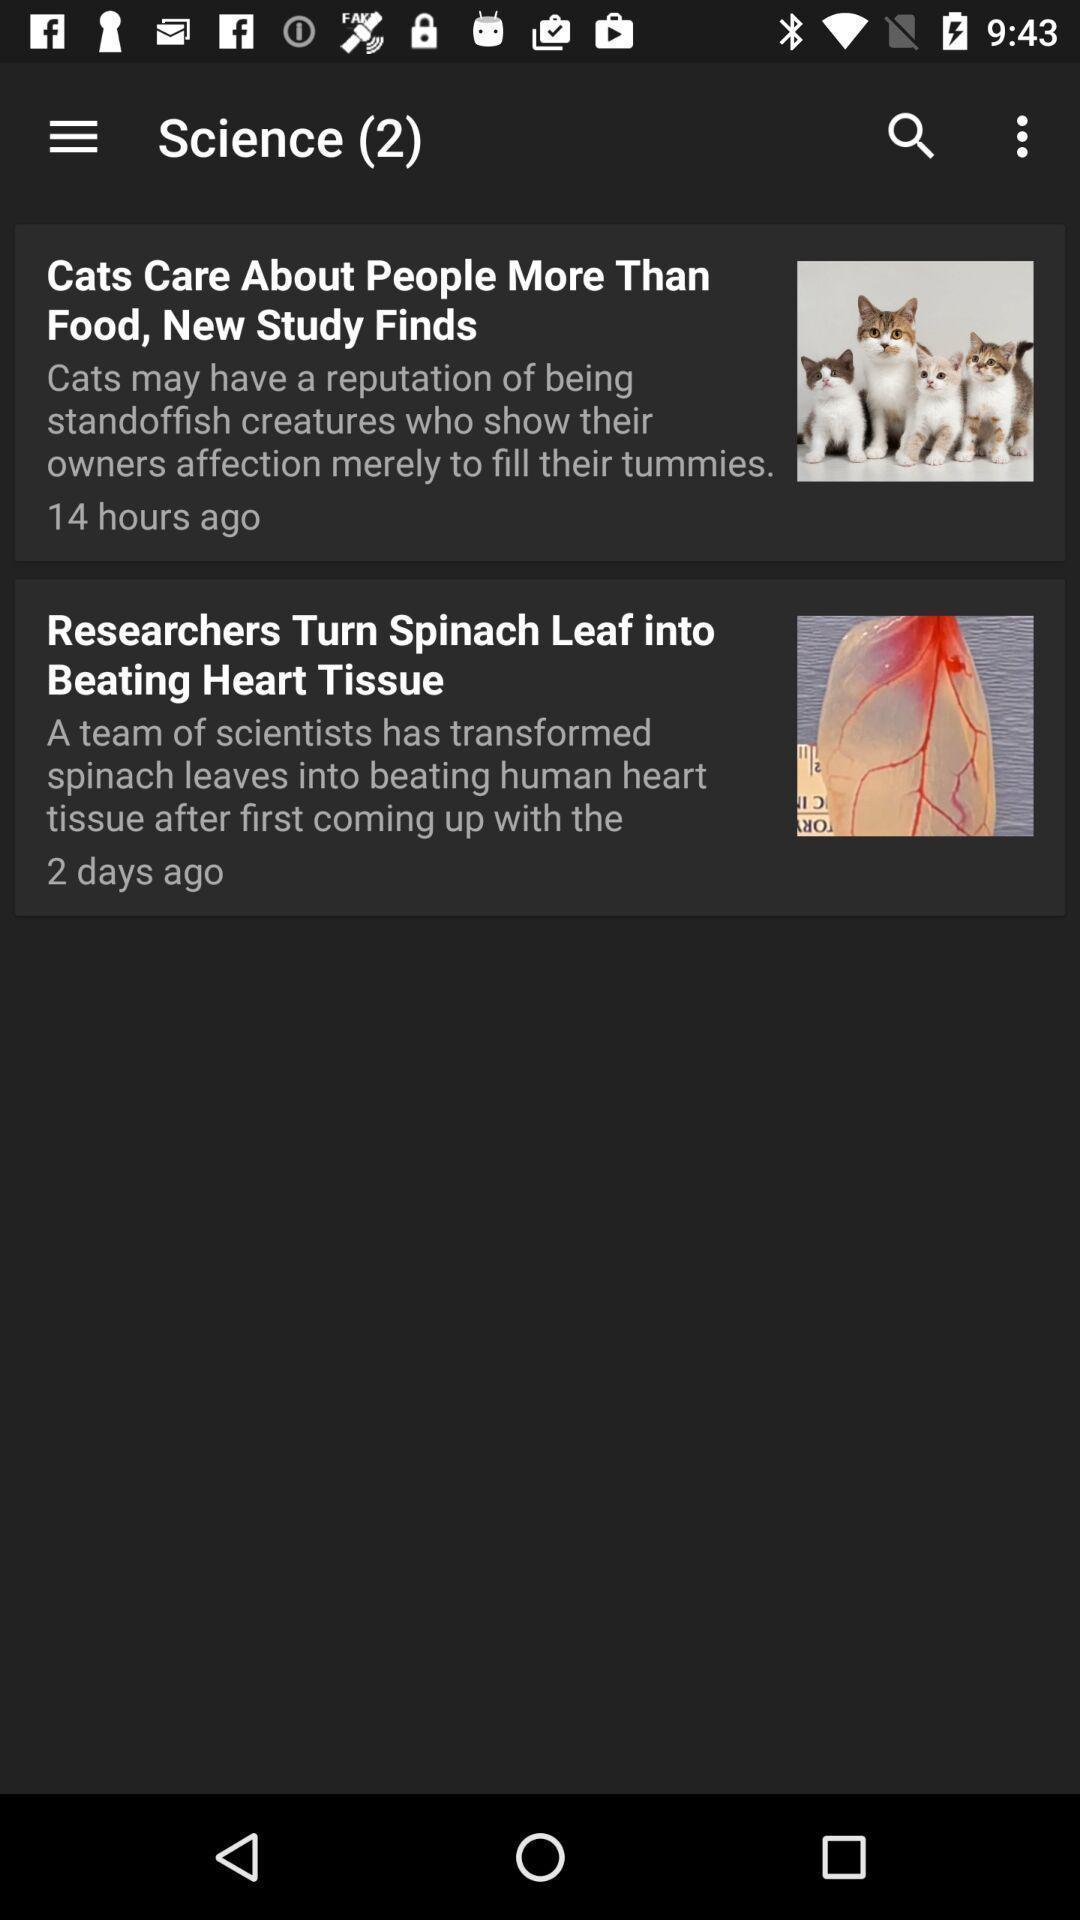What is the overall content of this screenshot? Page showing list of articles. 